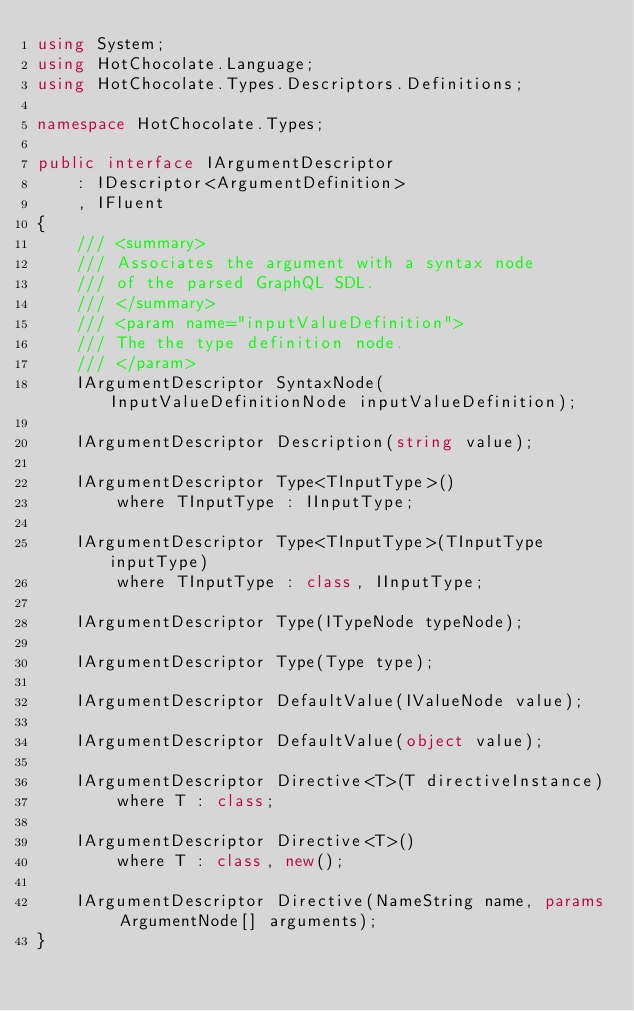Convert code to text. <code><loc_0><loc_0><loc_500><loc_500><_C#_>using System;
using HotChocolate.Language;
using HotChocolate.Types.Descriptors.Definitions;

namespace HotChocolate.Types;

public interface IArgumentDescriptor
    : IDescriptor<ArgumentDefinition>
    , IFluent
{
    /// <summary>
    /// Associates the argument with a syntax node
    /// of the parsed GraphQL SDL.
    /// </summary>
    /// <param name="inputValueDefinition">
    /// The the type definition node.
    /// </param>
    IArgumentDescriptor SyntaxNode(InputValueDefinitionNode inputValueDefinition);

    IArgumentDescriptor Description(string value);

    IArgumentDescriptor Type<TInputType>()
        where TInputType : IInputType;

    IArgumentDescriptor Type<TInputType>(TInputType inputType)
        where TInputType : class, IInputType;

    IArgumentDescriptor Type(ITypeNode typeNode);

    IArgumentDescriptor Type(Type type);

    IArgumentDescriptor DefaultValue(IValueNode value);

    IArgumentDescriptor DefaultValue(object value);

    IArgumentDescriptor Directive<T>(T directiveInstance)
        where T : class;

    IArgumentDescriptor Directive<T>()
        where T : class, new();

    IArgumentDescriptor Directive(NameString name, params ArgumentNode[] arguments);
}
</code> 